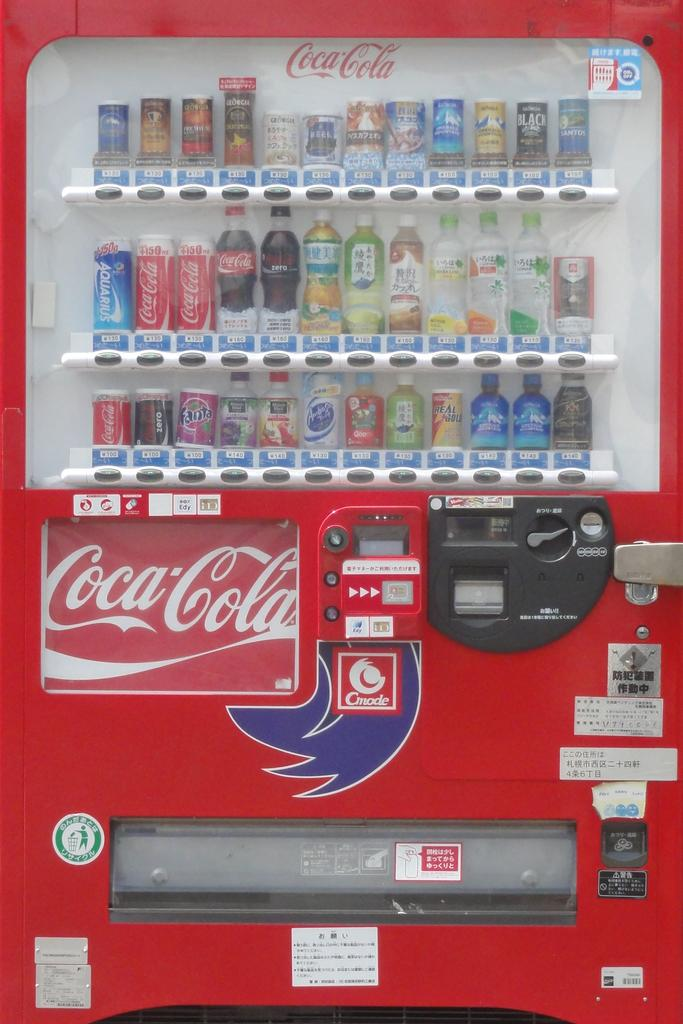<image>
Summarize the visual content of the image. A red Coca Cola vending machine offers many items for sale. 